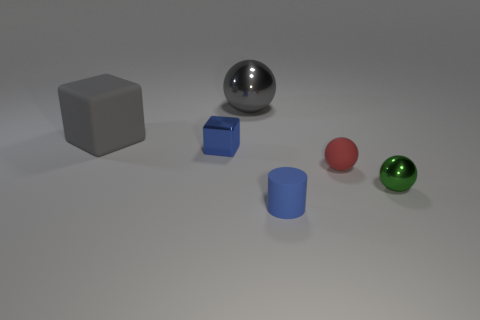The shiny block that is the same color as the tiny matte cylinder is what size?
Keep it short and to the point. Small. Is the shape of the blue object in front of the green metal ball the same as the metal thing in front of the small cube?
Provide a short and direct response. No. Are any small yellow spheres visible?
Your response must be concise. No. There is a matte sphere that is the same size as the green thing; what is its color?
Offer a terse response. Red. What number of green metal things have the same shape as the red matte thing?
Provide a succinct answer. 1. Are the gray object to the left of the gray metallic thing and the small block made of the same material?
Give a very brief answer. No. What number of cylinders are large cyan things or large gray rubber objects?
Keep it short and to the point. 0. What is the shape of the shiny thing to the right of the large gray shiny object that is behind the metal sphere on the right side of the big metallic sphere?
Make the answer very short. Sphere. The large metal thing that is the same color as the large rubber thing is what shape?
Your response must be concise. Sphere. How many red balls are the same size as the gray ball?
Provide a succinct answer. 0. 